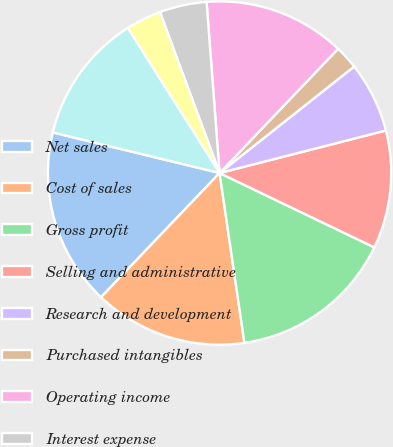Convert chart. <chart><loc_0><loc_0><loc_500><loc_500><pie_chart><fcel>Net sales<fcel>Cost of sales<fcel>Gross profit<fcel>Selling and administrative<fcel>Research and development<fcel>Purchased intangibles<fcel>Operating income<fcel>Interest expense<fcel>Interest income<fcel>Income from operations before<nl><fcel>16.67%<fcel>14.44%<fcel>15.56%<fcel>11.11%<fcel>6.67%<fcel>2.22%<fcel>13.33%<fcel>4.44%<fcel>3.33%<fcel>12.22%<nl></chart> 